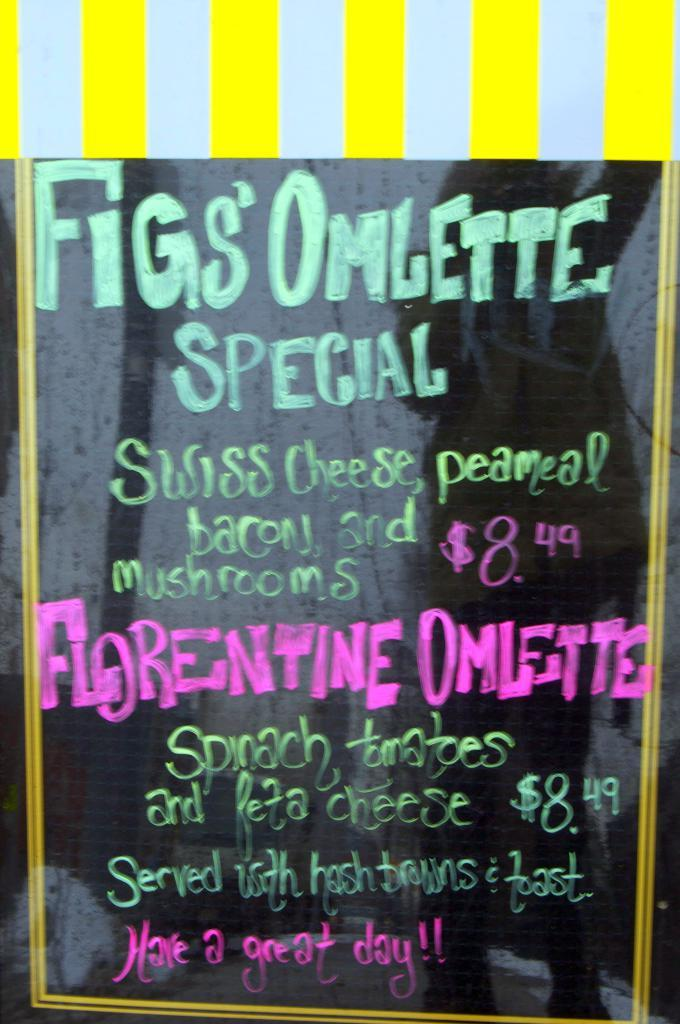<image>
Share a concise interpretation of the image provided. A chalkboard shows a restaurant's special, which is the florentine omlette. 